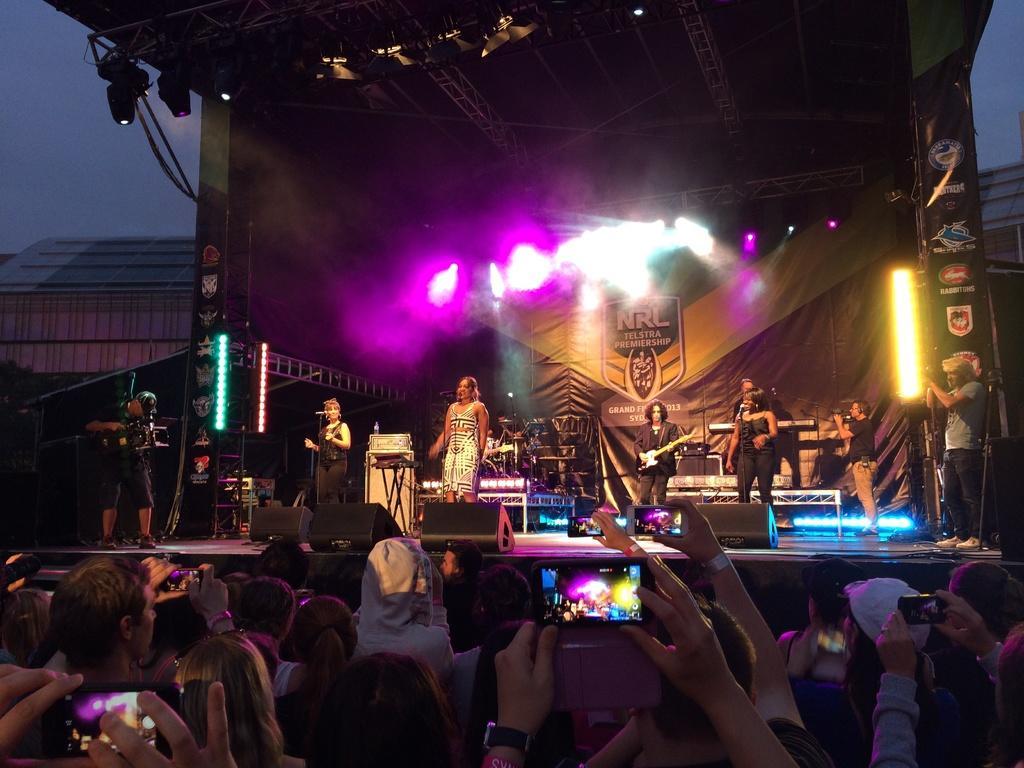In one or two sentences, can you explain what this image depicts? In this image i can see few people recording the concert in their cell phones, i can see few people standing on the stage, few of them are holding musical instruments in their hand and few of them are singing in front of microphone. In the background i can see some colorful lights, sky and a building. 